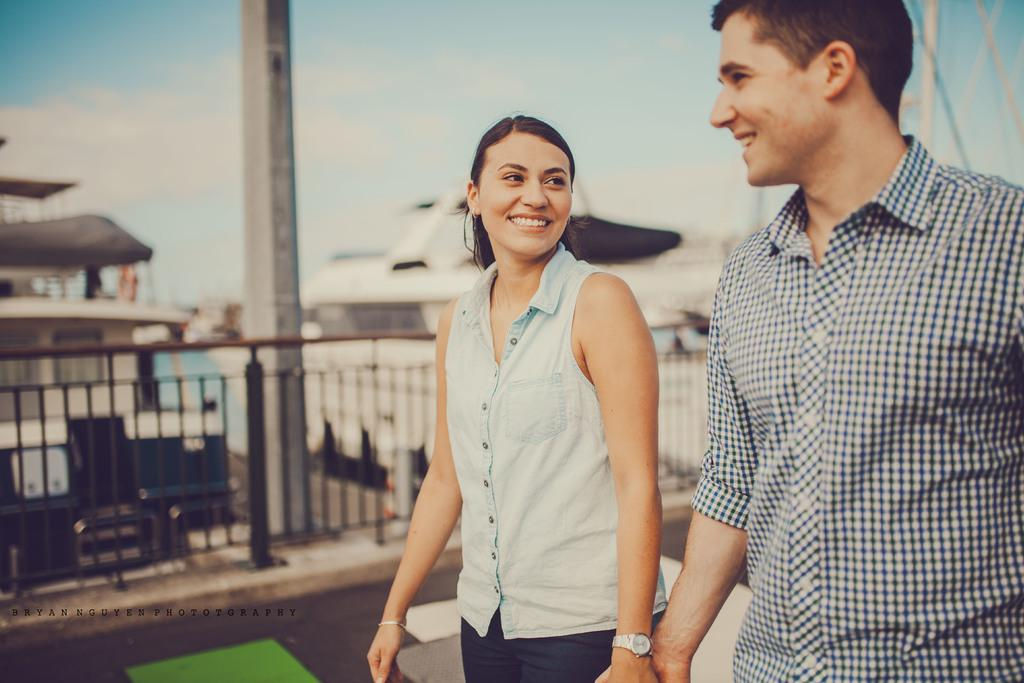How many people are in the image? There are two people in the image. What are the two people doing? The two people are holding hands and smiling. Can you describe the background of the image? The background of the image is blurry and includes a pole, ships, a fence, and the sky with clouds. Where are the ants crawling on the pan in the image? There are no ants or pans present in the image. What type of rock can be seen in the image? There is no rock present in the image. 